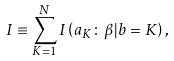<formula> <loc_0><loc_0><loc_500><loc_500>I \equiv \sum _ { K = 1 } ^ { N } I \left ( a _ { K } \colon \beta | b = K \right ) ,</formula> 